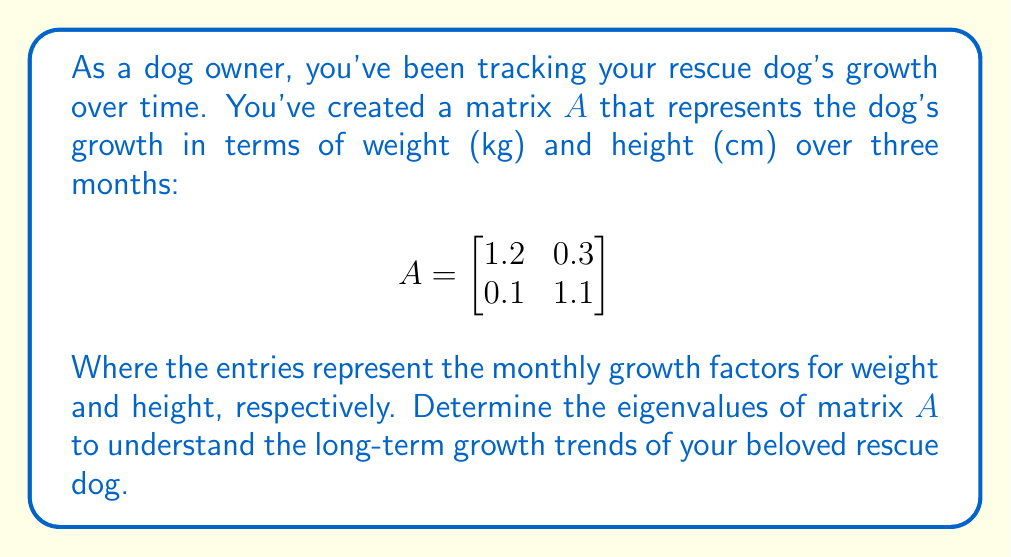Show me your answer to this math problem. To find the eigenvalues of matrix $A$, we need to solve the characteristic equation:

1) First, we set up the equation $det(A - \lambda I) = 0$, where $\lambda$ represents the eigenvalues and $I$ is the 2x2 identity matrix:

   $$det\begin{pmatrix}
   1.2 - \lambda & 0.3 \\
   0.1 & 1.1 - \lambda
   \end{pmatrix} = 0$$

2) Expand the determinant:
   $$(1.2 - \lambda)(1.1 - \lambda) - (0.3)(0.1) = 0$$

3) Multiply out the terms:
   $$1.32 - 1.2\lambda - 1.1\lambda + \lambda^2 - 0.03 = 0$$
   $$\lambda^2 - 2.3\lambda + 1.29 = 0$$

4) This is a quadratic equation. We can solve it using the quadratic formula:
   $$\lambda = \frac{-b \pm \sqrt{b^2 - 4ac}}{2a}$$

   Where $a=1$, $b=-2.3$, and $c=1.29$

5) Substituting these values:
   $$\lambda = \frac{2.3 \pm \sqrt{(-2.3)^2 - 4(1)(1.29)}}{2(1)}$$
   $$\lambda = \frac{2.3 \pm \sqrt{5.29 - 5.16}}{2}$$
   $$\lambda = \frac{2.3 \pm \sqrt{0.13}}{2}$$
   $$\lambda = \frac{2.3 \pm 0.36}{2}$$

6) This gives us two eigenvalues:
   $$\lambda_1 = \frac{2.3 + 0.36}{2} = 1.33$$
   $$\lambda_2 = \frac{2.3 - 0.36}{2} = 0.97$$
Answer: $\lambda_1 = 1.33$, $\lambda_2 = 0.97$ 